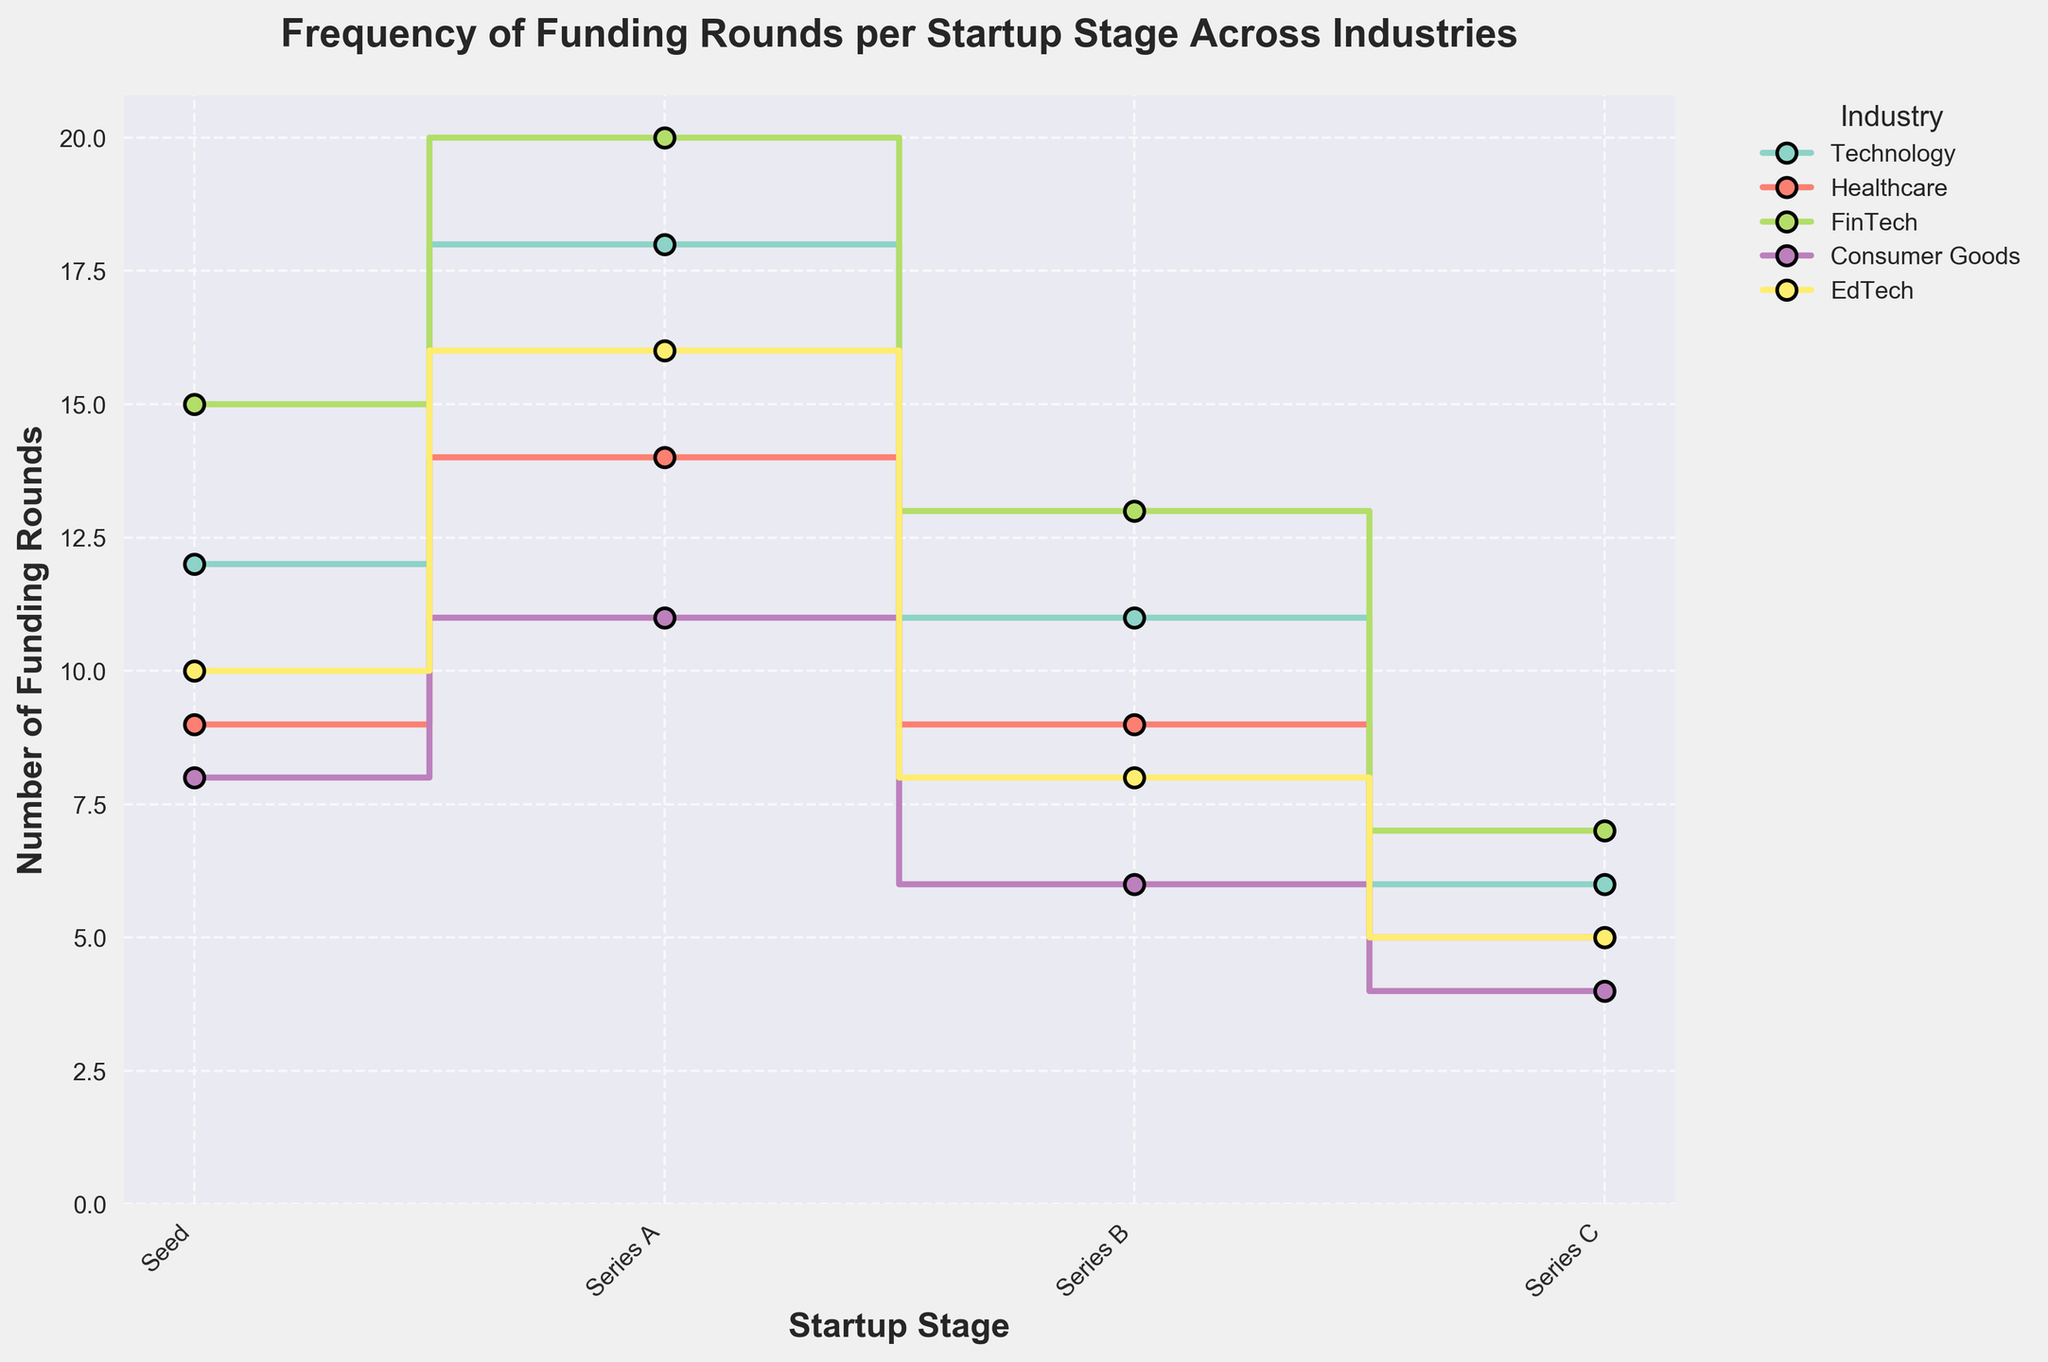What is the title of the figure? The title can be found at the top of the figure. It's the text meant to describe what the graph represents. The phrase appears there: 'Frequency of Funding Rounds per Startup Stage Across Industries'.
Answer: Frequency of Funding Rounds per Startup Stage Across Industries How many startup stages are represented in the plot? By counting the unique labels on the x-axis that denote different startup stages, we can determine how many stages are represented. These are Seed, Series A, Series B, and Series C.
Answer: 4 Which industry has the highest number of funding rounds in the Series A stage? By identifying the lines and markers corresponding to Series A and comparing their heights, we see that FinTech has the highest number of funding rounds with 20.
Answer: FinTech What is the difference in the number of funding rounds between the highest and lowest industry in the Seed stage? From the plot, FinTech has the highest number of funding rounds at the Seed stage with 15, and Consumer Goods has the lowest with 8. The difference is calculated as 15 - 8.
Answer: 7 Between which two consecutive startup stages does the Technology industry experience the largest drop in the number of funding rounds? By examining the trend of the Technology (color-coded) line, the largest drop is between Series A (18 rounds) and Series B (11 rounds). The decrease is 18 - 11.
Answer: Series A to Series B Comparing the Healthcare industry in the Seed stage and the EdTech industry in the Series B stage, which has more funding rounds? By locating the points for Healthcare at Seed stage (9) and EdTech at Series B (8), we can see that Healthcare at Seed stage has 1 round more.
Answer: Healthcare in Seed stage What is the average number of funding rounds for the Consumer Goods industry across all stages? Summing the number of rounds for Consumer Goods at all stages: Seed (8) + Series A (11) + Series B (6) + Series C (4), and then dividing by the number of stages, (8 + 11 + 6 + 4)/4 gives the average.
Answer: 7.25 Of all the industries at the Series C stage, which one has the least number of funding rounds? By evaluating the Series C stage across all industries, the Consumer Goods industry has the smallest value with 4 funding rounds.
Answer: Consumer Goods 